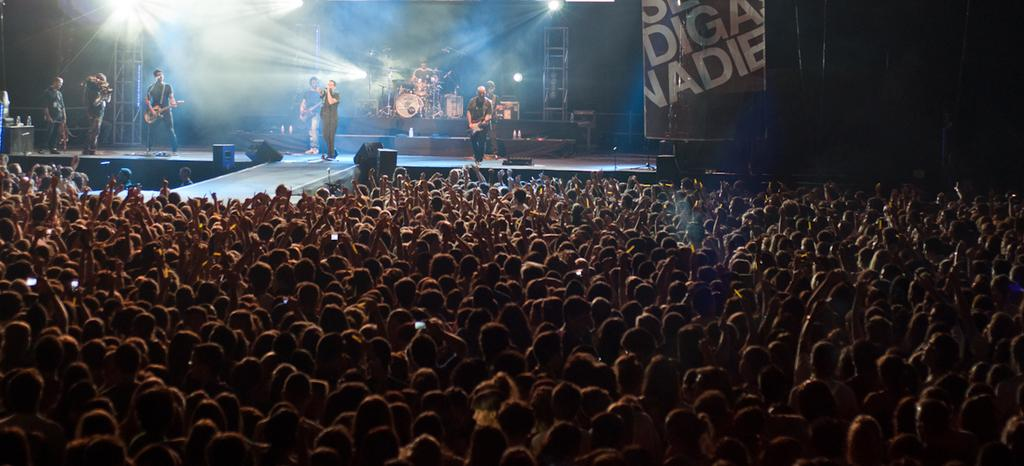How many people are in the image? There is a group of people in the image, but the exact number cannot be determined from the provided facts. Where are some of the people located in the image? Some people are on a stage in the image. What items are related to music in the image? Musical instruments and speakers are visible in the image. What type of lighting is present in the image? Lights are present in the image. Can you describe any other objects in the image? There are other objects in the image, but their specific nature cannot be determined from the provided facts. What type of corn is being served at the meeting in the image? There is no mention of corn or a meeting in the image, so it cannot be determined if corn is being served or if a meeting is taking place. 